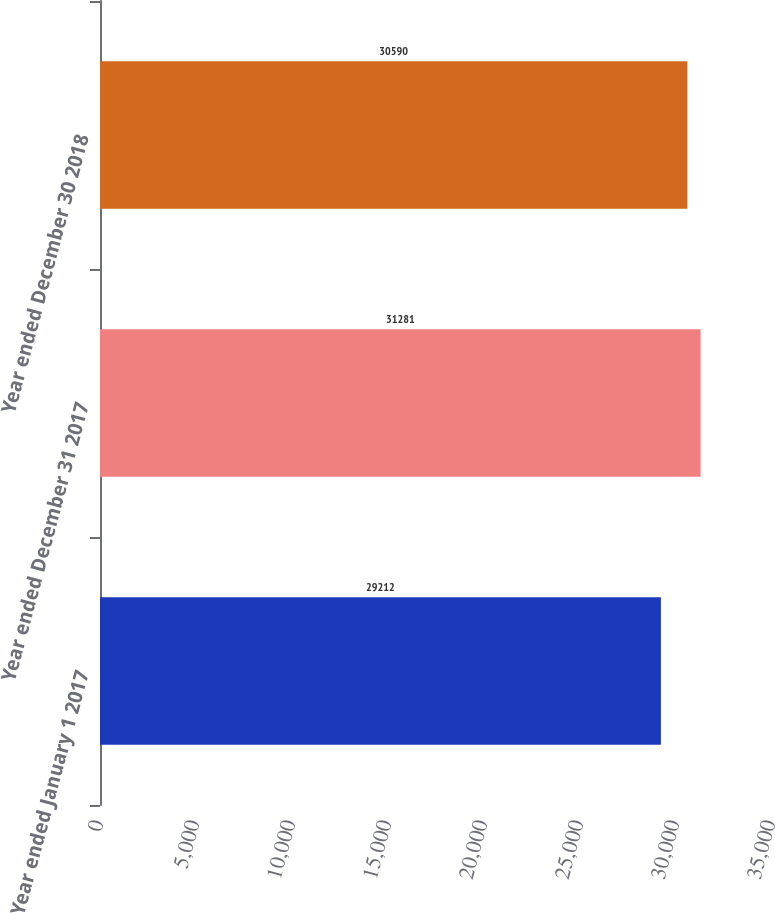Convert chart. <chart><loc_0><loc_0><loc_500><loc_500><bar_chart><fcel>Year ended January 1 2017<fcel>Year ended December 31 2017<fcel>Year ended December 30 2018<nl><fcel>29212<fcel>31281<fcel>30590<nl></chart> 